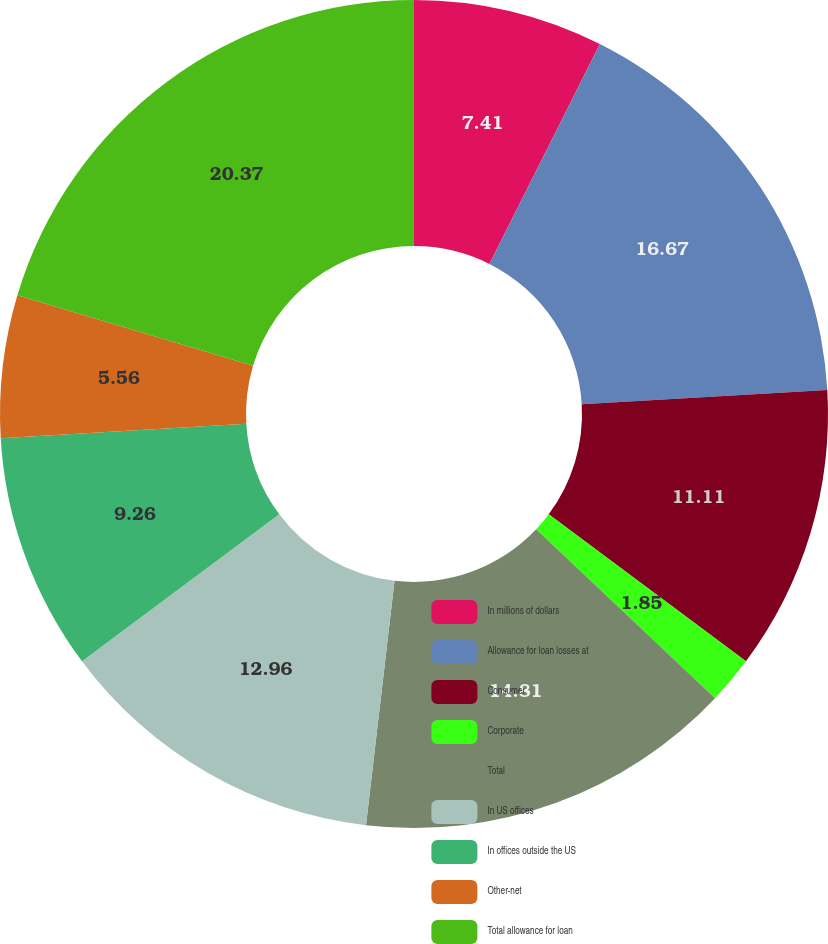Convert chart. <chart><loc_0><loc_0><loc_500><loc_500><pie_chart><fcel>In millions of dollars<fcel>Allowance for loan losses at<fcel>Consumer<fcel>Corporate<fcel>Total<fcel>In US offices<fcel>In offices outside the US<fcel>Other-net<fcel>Total allowance for loan<nl><fcel>7.41%<fcel>16.67%<fcel>11.11%<fcel>1.85%<fcel>14.81%<fcel>12.96%<fcel>9.26%<fcel>5.56%<fcel>20.37%<nl></chart> 